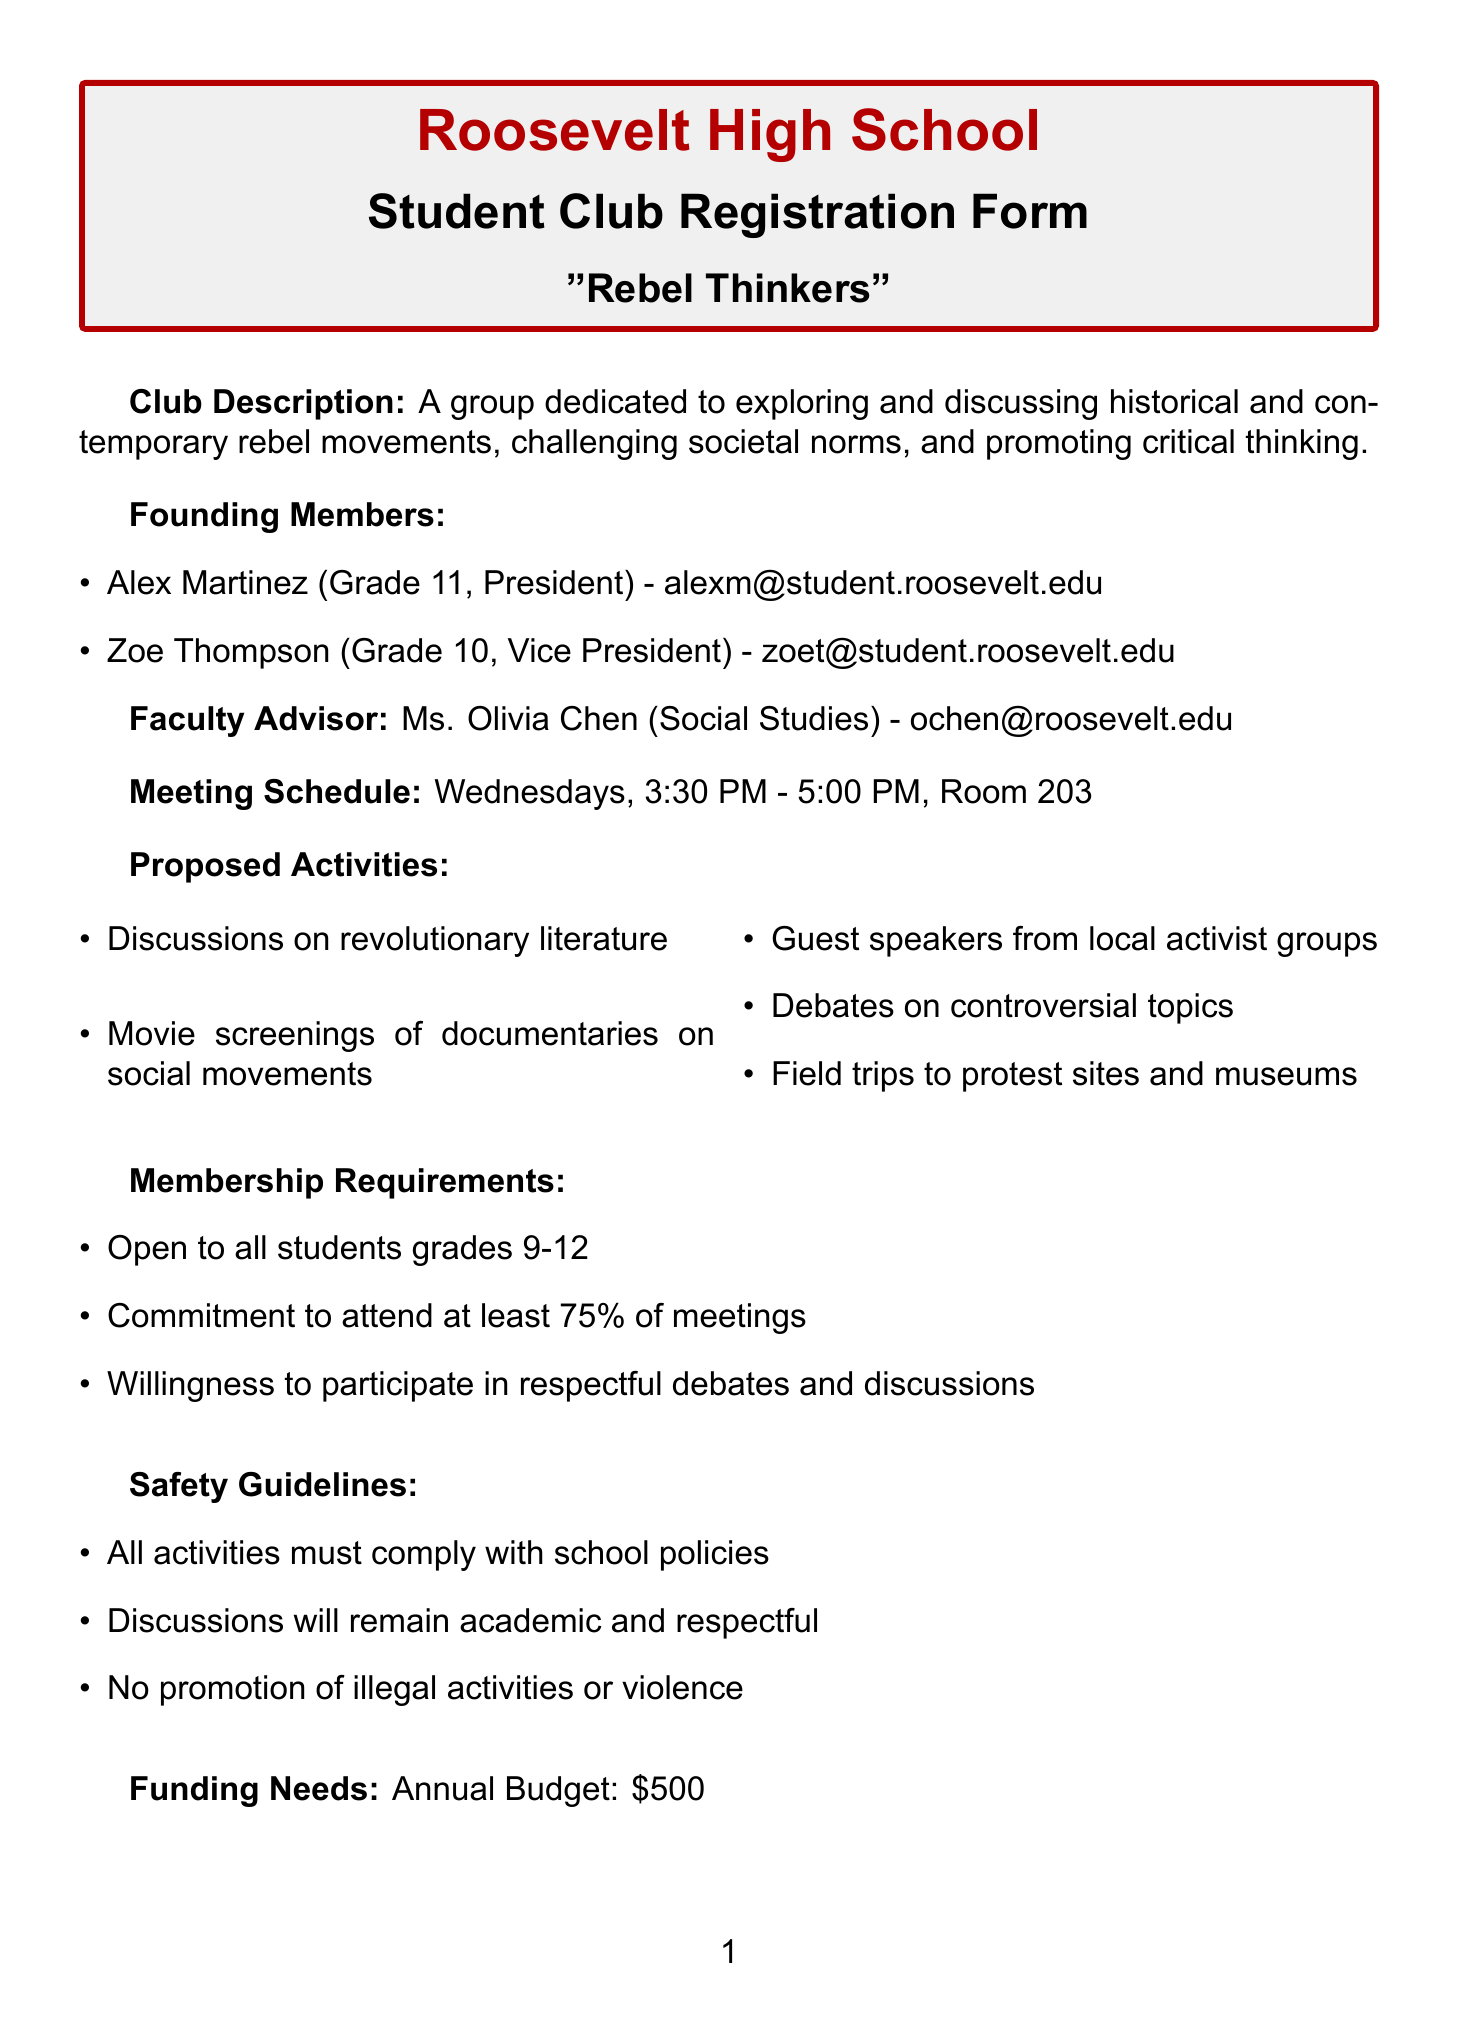What is the name of the club? The club is specifically titled "Rebel Thinkers" as mentioned at the top of the document.
Answer: Rebel Thinkers Who is the faculty advisor? The faculty advisor is listed in the document as Ms. Olivia Chen.
Answer: Ms. Olivia Chen What is the meeting schedule? The schedule outlines that meetings occur every Wednesday from 3:30 PM to 5:00 PM.
Answer: Wednesdays, 3:30 PM - 5:00 PM What is one proposed activity for the club? The document lists several activities; one example is discussions on revolutionary literature.
Answer: Discussions on revolutionary literature How many founding members are there? There are two founding members detailed in the document.
Answer: 2 What are the grade levels eligible for membership? The document specifies that the club is open to students in grades 9-12.
Answer: Grades 9-12 What is the annual budget for the club? The budget mentioned in the document is $500.
Answer: $500 What is the role of Alex Martinez? The document specifies that Alex Martinez holds the role of President.
Answer: President What is one safety guideline mentioned? One of the safety guidelines states that discussions will remain academic and respectful.
Answer: Discussions will remain academic and respectful Which social media platforms does the club have? The document mentions the club's presence on Instagram and Twitter, specifically handling those accounts.
Answer: Instagram and Twitter 